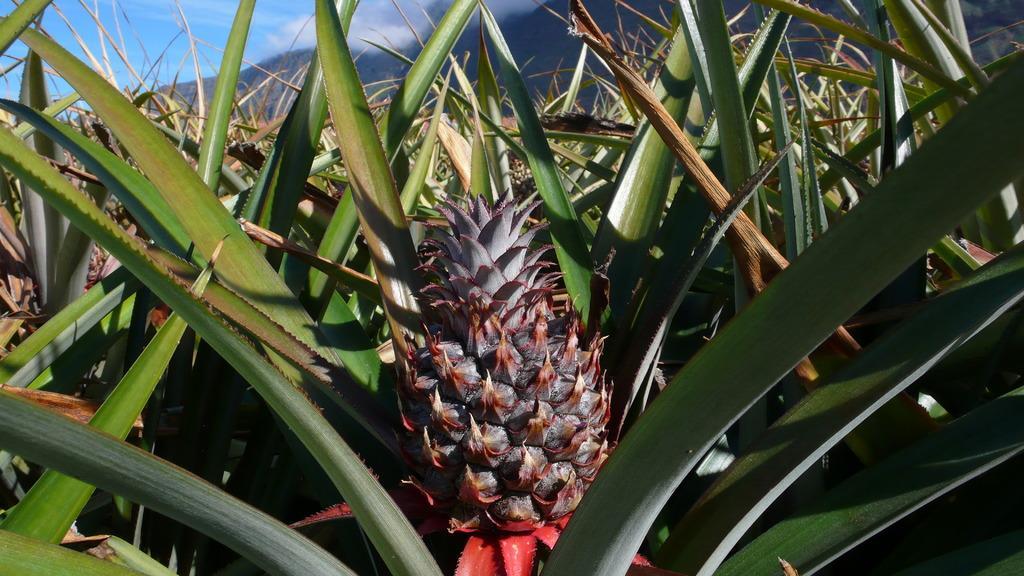Could you give a brief overview of what you see in this image? In this image I can see the field of pineapple. At the top of the image I can see the sky and clouds. 